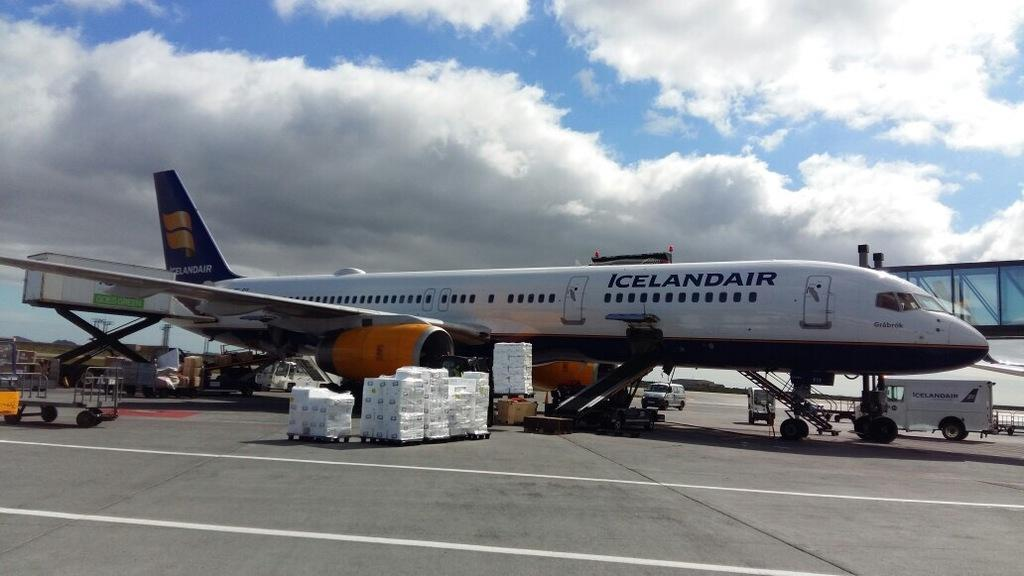Provide a one-sentence caption for the provided image. An airplane from icelanair at the terminal airport. 